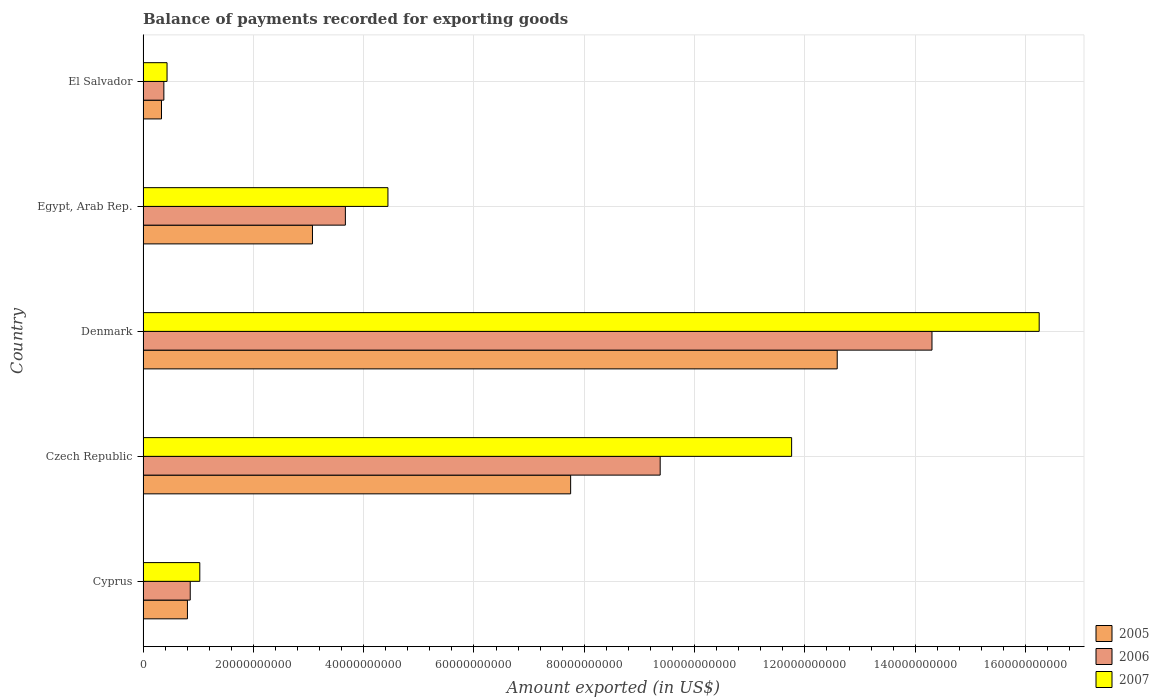How many different coloured bars are there?
Ensure brevity in your answer.  3. Are the number of bars per tick equal to the number of legend labels?
Provide a short and direct response. Yes. Are the number of bars on each tick of the Y-axis equal?
Keep it short and to the point. Yes. How many bars are there on the 2nd tick from the bottom?
Your response must be concise. 3. What is the label of the 5th group of bars from the top?
Ensure brevity in your answer.  Cyprus. In how many cases, is the number of bars for a given country not equal to the number of legend labels?
Your response must be concise. 0. What is the amount exported in 2006 in Denmark?
Keep it short and to the point. 1.43e+11. Across all countries, what is the maximum amount exported in 2007?
Offer a terse response. 1.62e+11. Across all countries, what is the minimum amount exported in 2006?
Keep it short and to the point. 3.77e+09. In which country was the amount exported in 2005 maximum?
Your answer should be compact. Denmark. In which country was the amount exported in 2005 minimum?
Provide a short and direct response. El Salvador. What is the total amount exported in 2006 in the graph?
Your answer should be very brief. 2.86e+11. What is the difference between the amount exported in 2006 in Cyprus and that in Denmark?
Your response must be concise. -1.34e+11. What is the difference between the amount exported in 2006 in El Salvador and the amount exported in 2007 in Cyprus?
Your response must be concise. -6.52e+09. What is the average amount exported in 2005 per country?
Offer a very short reply. 4.91e+1. What is the difference between the amount exported in 2006 and amount exported in 2005 in Cyprus?
Your response must be concise. 5.06e+08. What is the ratio of the amount exported in 2005 in Cyprus to that in Denmark?
Provide a short and direct response. 0.06. Is the amount exported in 2006 in Cyprus less than that in Egypt, Arab Rep.?
Make the answer very short. Yes. Is the difference between the amount exported in 2006 in Egypt, Arab Rep. and El Salvador greater than the difference between the amount exported in 2005 in Egypt, Arab Rep. and El Salvador?
Keep it short and to the point. Yes. What is the difference between the highest and the second highest amount exported in 2005?
Your response must be concise. 4.83e+1. What is the difference between the highest and the lowest amount exported in 2005?
Ensure brevity in your answer.  1.23e+11. Is the sum of the amount exported in 2006 in Cyprus and El Salvador greater than the maximum amount exported in 2005 across all countries?
Offer a very short reply. No. What does the 2nd bar from the top in Egypt, Arab Rep. represents?
Offer a terse response. 2006. What does the 2nd bar from the bottom in Denmark represents?
Make the answer very short. 2006. Is it the case that in every country, the sum of the amount exported in 2005 and amount exported in 2007 is greater than the amount exported in 2006?
Give a very brief answer. Yes. Are the values on the major ticks of X-axis written in scientific E-notation?
Provide a short and direct response. No. Does the graph contain grids?
Offer a very short reply. Yes. How many legend labels are there?
Your response must be concise. 3. What is the title of the graph?
Your answer should be compact. Balance of payments recorded for exporting goods. What is the label or title of the X-axis?
Ensure brevity in your answer.  Amount exported (in US$). What is the Amount exported (in US$) in 2005 in Cyprus?
Offer a very short reply. 8.05e+09. What is the Amount exported (in US$) of 2006 in Cyprus?
Your answer should be compact. 8.55e+09. What is the Amount exported (in US$) in 2007 in Cyprus?
Offer a terse response. 1.03e+1. What is the Amount exported (in US$) of 2005 in Czech Republic?
Offer a very short reply. 7.75e+1. What is the Amount exported (in US$) in 2006 in Czech Republic?
Ensure brevity in your answer.  9.38e+1. What is the Amount exported (in US$) of 2007 in Czech Republic?
Give a very brief answer. 1.18e+11. What is the Amount exported (in US$) of 2005 in Denmark?
Keep it short and to the point. 1.26e+11. What is the Amount exported (in US$) in 2006 in Denmark?
Offer a terse response. 1.43e+11. What is the Amount exported (in US$) of 2007 in Denmark?
Your answer should be very brief. 1.62e+11. What is the Amount exported (in US$) of 2005 in Egypt, Arab Rep.?
Give a very brief answer. 3.07e+1. What is the Amount exported (in US$) of 2006 in Egypt, Arab Rep.?
Ensure brevity in your answer.  3.67e+1. What is the Amount exported (in US$) of 2007 in Egypt, Arab Rep.?
Make the answer very short. 4.44e+1. What is the Amount exported (in US$) in 2005 in El Salvador?
Keep it short and to the point. 3.34e+09. What is the Amount exported (in US$) of 2006 in El Salvador?
Offer a very short reply. 3.77e+09. What is the Amount exported (in US$) of 2007 in El Salvador?
Provide a succinct answer. 4.35e+09. Across all countries, what is the maximum Amount exported (in US$) in 2005?
Keep it short and to the point. 1.26e+11. Across all countries, what is the maximum Amount exported (in US$) in 2006?
Ensure brevity in your answer.  1.43e+11. Across all countries, what is the maximum Amount exported (in US$) in 2007?
Provide a succinct answer. 1.62e+11. Across all countries, what is the minimum Amount exported (in US$) of 2005?
Offer a very short reply. 3.34e+09. Across all countries, what is the minimum Amount exported (in US$) in 2006?
Provide a short and direct response. 3.77e+09. Across all countries, what is the minimum Amount exported (in US$) of 2007?
Provide a succinct answer. 4.35e+09. What is the total Amount exported (in US$) in 2005 in the graph?
Your response must be concise. 2.45e+11. What is the total Amount exported (in US$) in 2006 in the graph?
Provide a succinct answer. 2.86e+11. What is the total Amount exported (in US$) of 2007 in the graph?
Keep it short and to the point. 3.39e+11. What is the difference between the Amount exported (in US$) in 2005 in Cyprus and that in Czech Republic?
Make the answer very short. -6.95e+1. What is the difference between the Amount exported (in US$) in 2006 in Cyprus and that in Czech Republic?
Your response must be concise. -8.52e+1. What is the difference between the Amount exported (in US$) in 2007 in Cyprus and that in Czech Republic?
Your answer should be very brief. -1.07e+11. What is the difference between the Amount exported (in US$) of 2005 in Cyprus and that in Denmark?
Offer a terse response. -1.18e+11. What is the difference between the Amount exported (in US$) in 2006 in Cyprus and that in Denmark?
Keep it short and to the point. -1.34e+11. What is the difference between the Amount exported (in US$) of 2007 in Cyprus and that in Denmark?
Keep it short and to the point. -1.52e+11. What is the difference between the Amount exported (in US$) of 2005 in Cyprus and that in Egypt, Arab Rep.?
Ensure brevity in your answer.  -2.27e+1. What is the difference between the Amount exported (in US$) of 2006 in Cyprus and that in Egypt, Arab Rep.?
Your answer should be very brief. -2.81e+1. What is the difference between the Amount exported (in US$) in 2007 in Cyprus and that in Egypt, Arab Rep.?
Make the answer very short. -3.41e+1. What is the difference between the Amount exported (in US$) of 2005 in Cyprus and that in El Salvador?
Provide a short and direct response. 4.70e+09. What is the difference between the Amount exported (in US$) of 2006 in Cyprus and that in El Salvador?
Give a very brief answer. 4.78e+09. What is the difference between the Amount exported (in US$) of 2007 in Cyprus and that in El Salvador?
Provide a succinct answer. 5.94e+09. What is the difference between the Amount exported (in US$) in 2005 in Czech Republic and that in Denmark?
Your response must be concise. -4.83e+1. What is the difference between the Amount exported (in US$) of 2006 in Czech Republic and that in Denmark?
Provide a succinct answer. -4.93e+1. What is the difference between the Amount exported (in US$) in 2007 in Czech Republic and that in Denmark?
Provide a succinct answer. -4.49e+1. What is the difference between the Amount exported (in US$) of 2005 in Czech Republic and that in Egypt, Arab Rep.?
Keep it short and to the point. 4.68e+1. What is the difference between the Amount exported (in US$) in 2006 in Czech Republic and that in Egypt, Arab Rep.?
Your answer should be very brief. 5.71e+1. What is the difference between the Amount exported (in US$) in 2007 in Czech Republic and that in Egypt, Arab Rep.?
Make the answer very short. 7.32e+1. What is the difference between the Amount exported (in US$) of 2005 in Czech Republic and that in El Salvador?
Your response must be concise. 7.42e+1. What is the difference between the Amount exported (in US$) in 2006 in Czech Republic and that in El Salvador?
Provide a short and direct response. 9.00e+1. What is the difference between the Amount exported (in US$) in 2007 in Czech Republic and that in El Salvador?
Your answer should be very brief. 1.13e+11. What is the difference between the Amount exported (in US$) of 2005 in Denmark and that in Egypt, Arab Rep.?
Give a very brief answer. 9.51e+1. What is the difference between the Amount exported (in US$) in 2006 in Denmark and that in Egypt, Arab Rep.?
Keep it short and to the point. 1.06e+11. What is the difference between the Amount exported (in US$) of 2007 in Denmark and that in Egypt, Arab Rep.?
Give a very brief answer. 1.18e+11. What is the difference between the Amount exported (in US$) of 2005 in Denmark and that in El Salvador?
Your answer should be very brief. 1.23e+11. What is the difference between the Amount exported (in US$) in 2006 in Denmark and that in El Salvador?
Your answer should be compact. 1.39e+11. What is the difference between the Amount exported (in US$) of 2007 in Denmark and that in El Salvador?
Your answer should be very brief. 1.58e+11. What is the difference between the Amount exported (in US$) of 2005 in Egypt, Arab Rep. and that in El Salvador?
Offer a terse response. 2.74e+1. What is the difference between the Amount exported (in US$) in 2006 in Egypt, Arab Rep. and that in El Salvador?
Your answer should be compact. 3.29e+1. What is the difference between the Amount exported (in US$) of 2007 in Egypt, Arab Rep. and that in El Salvador?
Offer a very short reply. 4.00e+1. What is the difference between the Amount exported (in US$) of 2005 in Cyprus and the Amount exported (in US$) of 2006 in Czech Republic?
Give a very brief answer. -8.57e+1. What is the difference between the Amount exported (in US$) in 2005 in Cyprus and the Amount exported (in US$) in 2007 in Czech Republic?
Provide a short and direct response. -1.10e+11. What is the difference between the Amount exported (in US$) in 2006 in Cyprus and the Amount exported (in US$) in 2007 in Czech Republic?
Offer a very short reply. -1.09e+11. What is the difference between the Amount exported (in US$) in 2005 in Cyprus and the Amount exported (in US$) in 2006 in Denmark?
Offer a terse response. -1.35e+11. What is the difference between the Amount exported (in US$) in 2005 in Cyprus and the Amount exported (in US$) in 2007 in Denmark?
Ensure brevity in your answer.  -1.54e+11. What is the difference between the Amount exported (in US$) of 2006 in Cyprus and the Amount exported (in US$) of 2007 in Denmark?
Make the answer very short. -1.54e+11. What is the difference between the Amount exported (in US$) of 2005 in Cyprus and the Amount exported (in US$) of 2006 in Egypt, Arab Rep.?
Your response must be concise. -2.86e+1. What is the difference between the Amount exported (in US$) in 2005 in Cyprus and the Amount exported (in US$) in 2007 in Egypt, Arab Rep.?
Offer a very short reply. -3.64e+1. What is the difference between the Amount exported (in US$) of 2006 in Cyprus and the Amount exported (in US$) of 2007 in Egypt, Arab Rep.?
Provide a short and direct response. -3.58e+1. What is the difference between the Amount exported (in US$) of 2005 in Cyprus and the Amount exported (in US$) of 2006 in El Salvador?
Offer a terse response. 4.28e+09. What is the difference between the Amount exported (in US$) of 2005 in Cyprus and the Amount exported (in US$) of 2007 in El Salvador?
Give a very brief answer. 3.70e+09. What is the difference between the Amount exported (in US$) in 2006 in Cyprus and the Amount exported (in US$) in 2007 in El Salvador?
Your answer should be compact. 4.20e+09. What is the difference between the Amount exported (in US$) in 2005 in Czech Republic and the Amount exported (in US$) in 2006 in Denmark?
Your answer should be compact. -6.55e+1. What is the difference between the Amount exported (in US$) in 2005 in Czech Republic and the Amount exported (in US$) in 2007 in Denmark?
Offer a very short reply. -8.50e+1. What is the difference between the Amount exported (in US$) in 2006 in Czech Republic and the Amount exported (in US$) in 2007 in Denmark?
Make the answer very short. -6.87e+1. What is the difference between the Amount exported (in US$) of 2005 in Czech Republic and the Amount exported (in US$) of 2006 in Egypt, Arab Rep.?
Make the answer very short. 4.08e+1. What is the difference between the Amount exported (in US$) of 2005 in Czech Republic and the Amount exported (in US$) of 2007 in Egypt, Arab Rep.?
Provide a short and direct response. 3.31e+1. What is the difference between the Amount exported (in US$) in 2006 in Czech Republic and the Amount exported (in US$) in 2007 in Egypt, Arab Rep.?
Your response must be concise. 4.94e+1. What is the difference between the Amount exported (in US$) of 2005 in Czech Republic and the Amount exported (in US$) of 2006 in El Salvador?
Your answer should be very brief. 7.38e+1. What is the difference between the Amount exported (in US$) in 2005 in Czech Republic and the Amount exported (in US$) in 2007 in El Salvador?
Offer a terse response. 7.32e+1. What is the difference between the Amount exported (in US$) of 2006 in Czech Republic and the Amount exported (in US$) of 2007 in El Salvador?
Your answer should be very brief. 8.94e+1. What is the difference between the Amount exported (in US$) of 2005 in Denmark and the Amount exported (in US$) of 2006 in Egypt, Arab Rep.?
Your answer should be compact. 8.92e+1. What is the difference between the Amount exported (in US$) of 2005 in Denmark and the Amount exported (in US$) of 2007 in Egypt, Arab Rep.?
Keep it short and to the point. 8.15e+1. What is the difference between the Amount exported (in US$) of 2006 in Denmark and the Amount exported (in US$) of 2007 in Egypt, Arab Rep.?
Keep it short and to the point. 9.86e+1. What is the difference between the Amount exported (in US$) of 2005 in Denmark and the Amount exported (in US$) of 2006 in El Salvador?
Your answer should be very brief. 1.22e+11. What is the difference between the Amount exported (in US$) of 2005 in Denmark and the Amount exported (in US$) of 2007 in El Salvador?
Provide a short and direct response. 1.22e+11. What is the difference between the Amount exported (in US$) of 2006 in Denmark and the Amount exported (in US$) of 2007 in El Salvador?
Make the answer very short. 1.39e+11. What is the difference between the Amount exported (in US$) of 2005 in Egypt, Arab Rep. and the Amount exported (in US$) of 2006 in El Salvador?
Your response must be concise. 2.69e+1. What is the difference between the Amount exported (in US$) of 2005 in Egypt, Arab Rep. and the Amount exported (in US$) of 2007 in El Salvador?
Provide a short and direct response. 2.64e+1. What is the difference between the Amount exported (in US$) in 2006 in Egypt, Arab Rep. and the Amount exported (in US$) in 2007 in El Salvador?
Give a very brief answer. 3.23e+1. What is the average Amount exported (in US$) in 2005 per country?
Give a very brief answer. 4.91e+1. What is the average Amount exported (in US$) of 2006 per country?
Provide a short and direct response. 5.72e+1. What is the average Amount exported (in US$) in 2007 per country?
Provide a short and direct response. 6.78e+1. What is the difference between the Amount exported (in US$) in 2005 and Amount exported (in US$) in 2006 in Cyprus?
Make the answer very short. -5.06e+08. What is the difference between the Amount exported (in US$) of 2005 and Amount exported (in US$) of 2007 in Cyprus?
Ensure brevity in your answer.  -2.24e+09. What is the difference between the Amount exported (in US$) of 2006 and Amount exported (in US$) of 2007 in Cyprus?
Your answer should be compact. -1.73e+09. What is the difference between the Amount exported (in US$) in 2005 and Amount exported (in US$) in 2006 in Czech Republic?
Your answer should be compact. -1.62e+1. What is the difference between the Amount exported (in US$) of 2005 and Amount exported (in US$) of 2007 in Czech Republic?
Your answer should be compact. -4.01e+1. What is the difference between the Amount exported (in US$) in 2006 and Amount exported (in US$) in 2007 in Czech Republic?
Offer a terse response. -2.38e+1. What is the difference between the Amount exported (in US$) in 2005 and Amount exported (in US$) in 2006 in Denmark?
Offer a very short reply. -1.72e+1. What is the difference between the Amount exported (in US$) in 2005 and Amount exported (in US$) in 2007 in Denmark?
Offer a terse response. -3.66e+1. What is the difference between the Amount exported (in US$) of 2006 and Amount exported (in US$) of 2007 in Denmark?
Your response must be concise. -1.94e+1. What is the difference between the Amount exported (in US$) of 2005 and Amount exported (in US$) of 2006 in Egypt, Arab Rep.?
Offer a terse response. -5.96e+09. What is the difference between the Amount exported (in US$) in 2005 and Amount exported (in US$) in 2007 in Egypt, Arab Rep.?
Ensure brevity in your answer.  -1.37e+1. What is the difference between the Amount exported (in US$) of 2006 and Amount exported (in US$) of 2007 in Egypt, Arab Rep.?
Provide a succinct answer. -7.72e+09. What is the difference between the Amount exported (in US$) of 2005 and Amount exported (in US$) of 2006 in El Salvador?
Make the answer very short. -4.29e+08. What is the difference between the Amount exported (in US$) in 2005 and Amount exported (in US$) in 2007 in El Salvador?
Offer a very short reply. -1.01e+09. What is the difference between the Amount exported (in US$) of 2006 and Amount exported (in US$) of 2007 in El Salvador?
Make the answer very short. -5.79e+08. What is the ratio of the Amount exported (in US$) in 2005 in Cyprus to that in Czech Republic?
Your answer should be compact. 0.1. What is the ratio of the Amount exported (in US$) of 2006 in Cyprus to that in Czech Republic?
Provide a succinct answer. 0.09. What is the ratio of the Amount exported (in US$) of 2007 in Cyprus to that in Czech Republic?
Offer a terse response. 0.09. What is the ratio of the Amount exported (in US$) of 2005 in Cyprus to that in Denmark?
Give a very brief answer. 0.06. What is the ratio of the Amount exported (in US$) in 2006 in Cyprus to that in Denmark?
Ensure brevity in your answer.  0.06. What is the ratio of the Amount exported (in US$) of 2007 in Cyprus to that in Denmark?
Provide a short and direct response. 0.06. What is the ratio of the Amount exported (in US$) in 2005 in Cyprus to that in Egypt, Arab Rep.?
Keep it short and to the point. 0.26. What is the ratio of the Amount exported (in US$) in 2006 in Cyprus to that in Egypt, Arab Rep.?
Provide a succinct answer. 0.23. What is the ratio of the Amount exported (in US$) of 2007 in Cyprus to that in Egypt, Arab Rep.?
Ensure brevity in your answer.  0.23. What is the ratio of the Amount exported (in US$) of 2005 in Cyprus to that in El Salvador?
Ensure brevity in your answer.  2.41. What is the ratio of the Amount exported (in US$) in 2006 in Cyprus to that in El Salvador?
Ensure brevity in your answer.  2.27. What is the ratio of the Amount exported (in US$) in 2007 in Cyprus to that in El Salvador?
Your answer should be very brief. 2.36. What is the ratio of the Amount exported (in US$) of 2005 in Czech Republic to that in Denmark?
Your answer should be compact. 0.62. What is the ratio of the Amount exported (in US$) of 2006 in Czech Republic to that in Denmark?
Provide a short and direct response. 0.66. What is the ratio of the Amount exported (in US$) in 2007 in Czech Republic to that in Denmark?
Keep it short and to the point. 0.72. What is the ratio of the Amount exported (in US$) of 2005 in Czech Republic to that in Egypt, Arab Rep.?
Offer a terse response. 2.52. What is the ratio of the Amount exported (in US$) of 2006 in Czech Republic to that in Egypt, Arab Rep.?
Your response must be concise. 2.56. What is the ratio of the Amount exported (in US$) of 2007 in Czech Republic to that in Egypt, Arab Rep.?
Ensure brevity in your answer.  2.65. What is the ratio of the Amount exported (in US$) in 2005 in Czech Republic to that in El Salvador?
Keep it short and to the point. 23.2. What is the ratio of the Amount exported (in US$) of 2006 in Czech Republic to that in El Salvador?
Provide a short and direct response. 24.87. What is the ratio of the Amount exported (in US$) of 2007 in Czech Republic to that in El Salvador?
Offer a terse response. 27.04. What is the ratio of the Amount exported (in US$) in 2005 in Denmark to that in Egypt, Arab Rep.?
Offer a terse response. 4.1. What is the ratio of the Amount exported (in US$) of 2006 in Denmark to that in Egypt, Arab Rep.?
Keep it short and to the point. 3.9. What is the ratio of the Amount exported (in US$) of 2007 in Denmark to that in Egypt, Arab Rep.?
Provide a short and direct response. 3.66. What is the ratio of the Amount exported (in US$) of 2005 in Denmark to that in El Salvador?
Make the answer very short. 37.66. What is the ratio of the Amount exported (in US$) in 2006 in Denmark to that in El Salvador?
Your response must be concise. 37.93. What is the ratio of the Amount exported (in US$) in 2007 in Denmark to that in El Salvador?
Ensure brevity in your answer.  37.36. What is the ratio of the Amount exported (in US$) in 2005 in Egypt, Arab Rep. to that in El Salvador?
Provide a succinct answer. 9.19. What is the ratio of the Amount exported (in US$) of 2006 in Egypt, Arab Rep. to that in El Salvador?
Your answer should be compact. 9.73. What is the ratio of the Amount exported (in US$) of 2007 in Egypt, Arab Rep. to that in El Salvador?
Ensure brevity in your answer.  10.21. What is the difference between the highest and the second highest Amount exported (in US$) in 2005?
Provide a short and direct response. 4.83e+1. What is the difference between the highest and the second highest Amount exported (in US$) of 2006?
Your response must be concise. 4.93e+1. What is the difference between the highest and the second highest Amount exported (in US$) in 2007?
Ensure brevity in your answer.  4.49e+1. What is the difference between the highest and the lowest Amount exported (in US$) in 2005?
Offer a very short reply. 1.23e+11. What is the difference between the highest and the lowest Amount exported (in US$) in 2006?
Your answer should be compact. 1.39e+11. What is the difference between the highest and the lowest Amount exported (in US$) in 2007?
Your answer should be very brief. 1.58e+11. 